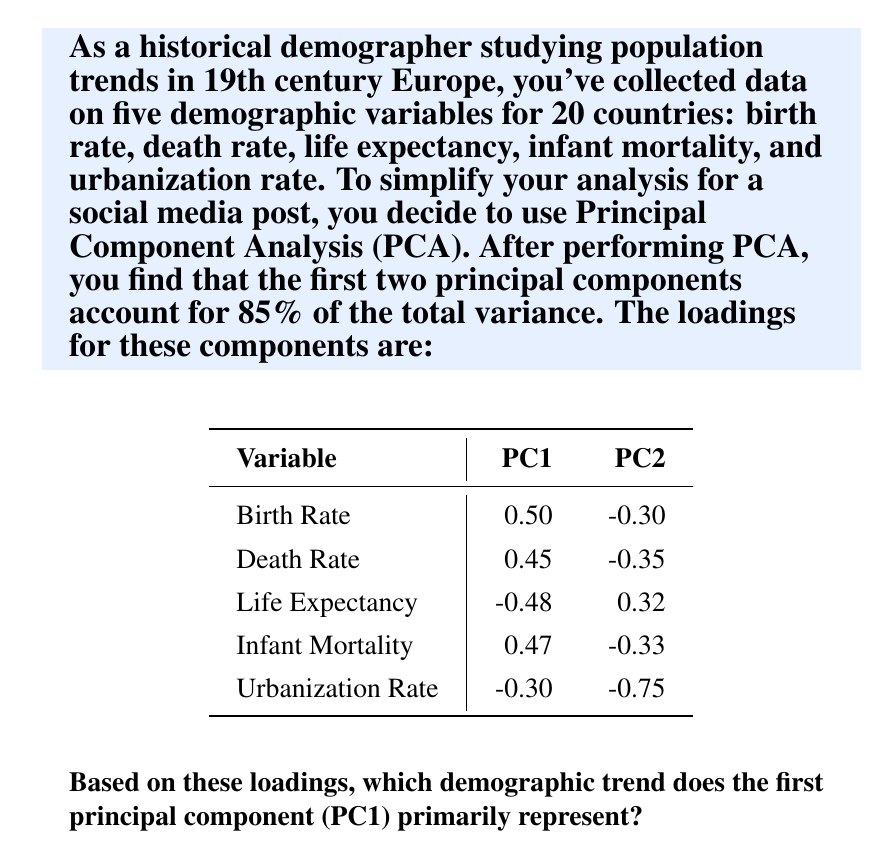Can you answer this question? To interpret the principal components, we need to examine the loadings for each variable:

1. Analyze PC1 loadings:
   - Birth Rate: 0.50 (strong positive)
   - Death Rate: 0.45 (moderate positive)
   - Life Expectancy: -0.48 (strong negative)
   - Infant Mortality: 0.47 (moderate positive)
   - Urbanization Rate: -0.30 (weak negative)

2. Interpret the pattern:
   - PC1 has strong positive loadings for Birth Rate and Infant Mortality.
   - It has moderate positive loading for Death Rate.
   - It has a strong negative loading for Life Expectancy.
   - The Urbanization Rate has a relatively weak negative loading.

3. Synthesize the information:
   - High positive values for PC1 correspond to high birth rates, high death rates, high infant mortality, and low life expectancy.
   - These characteristics are typically associated with less developed or pre-industrial populations.
   - Low values for PC1 would indicate the opposite: low birth rates, low death rates, low infant mortality, and high life expectancy, which are characteristics of more developed or industrialized populations.

4. Conclusion:
   The first principal component (PC1) primarily represents the overall level of demographic development or the stage in the demographic transition. It contrasts countries with high fertility, high mortality, and low life expectancy (typical of pre-industrial societies) against those with low fertility, low mortality, and high life expectancy (characteristic of more industrialized societies).
Answer: Demographic development / Stage in demographic transition 